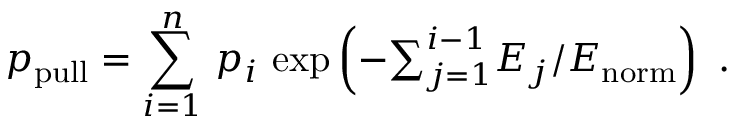<formula> <loc_0><loc_0><loc_500><loc_500>p _ { p u l l } = \sum _ { i = 1 } ^ { n } \, p _ { i } \, \exp \left ( - { \sum } _ { j = 1 } ^ { i - 1 } E _ { j } / E _ { n o r m } \right ) .</formula> 